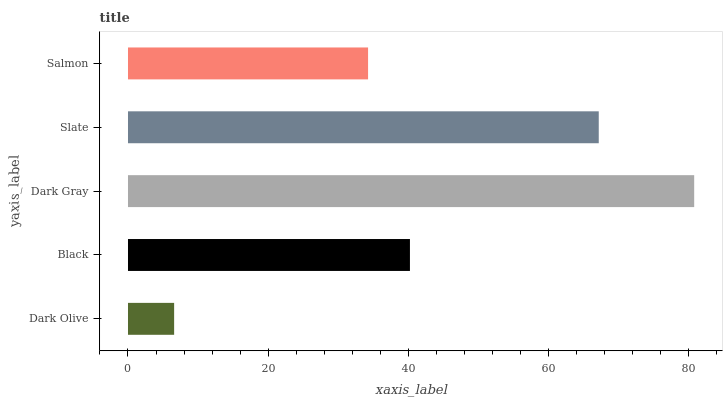Is Dark Olive the minimum?
Answer yes or no. Yes. Is Dark Gray the maximum?
Answer yes or no. Yes. Is Black the minimum?
Answer yes or no. No. Is Black the maximum?
Answer yes or no. No. Is Black greater than Dark Olive?
Answer yes or no. Yes. Is Dark Olive less than Black?
Answer yes or no. Yes. Is Dark Olive greater than Black?
Answer yes or no. No. Is Black less than Dark Olive?
Answer yes or no. No. Is Black the high median?
Answer yes or no. Yes. Is Black the low median?
Answer yes or no. Yes. Is Dark Gray the high median?
Answer yes or no. No. Is Dark Olive the low median?
Answer yes or no. No. 